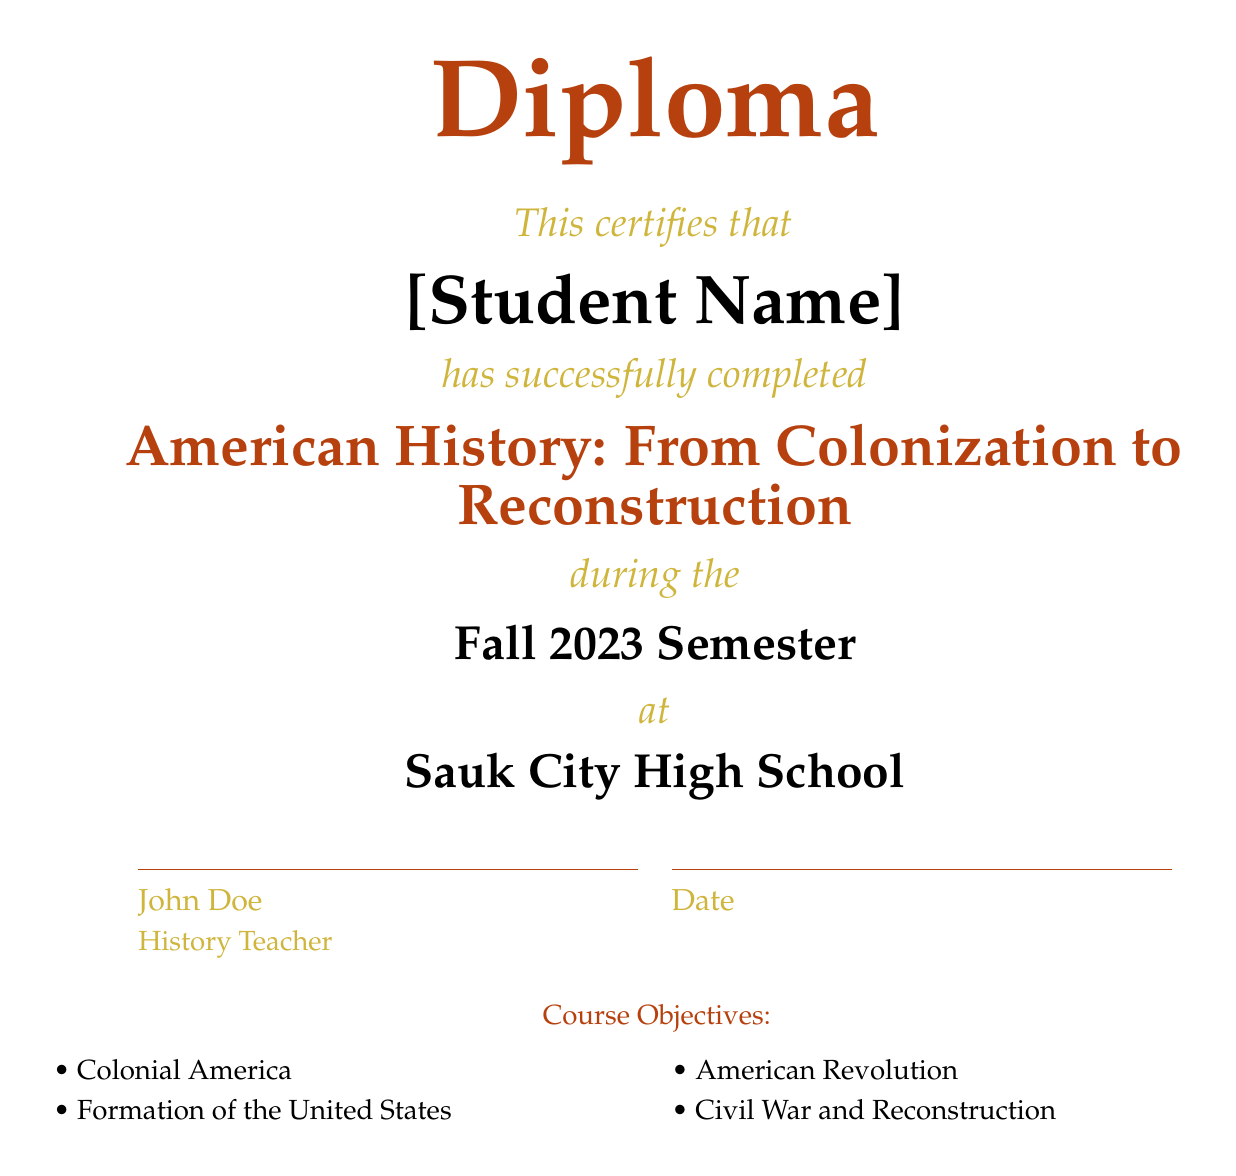What is the title of the course? The title of the course is stated explicitly in the document as "American History: From Colonization to Reconstruction."
Answer: American History: From Colonization to Reconstruction Who is the certificate issued to? The document specifies that the certificate is issued to "[Student Name]."
Answer: [Student Name] What is the semester in which the course was completed? The document mentions that the course was completed during the "Fall 2023 Semester."
Answer: Fall 2023 Semester What is the name of the high school? The diploma indicates the name of the high school as "Sauk City High School."
Answer: Sauk City High School How many course objectives are listed? There are a total of four course objectives mentioned in the document.
Answer: Four Who is the history teacher? The history teacher's name is given in the document as "John Doe."
Answer: John Doe What are the two course topics related to the early United States? The document lists "Formation of the United States" and "Civil War and Reconstruction" as course topics.
Answer: Formation of the United States and Civil War and Reconstruction What color is used for the diploma title? The color for the diploma title is specified as "rustred."
Answer: rustred 